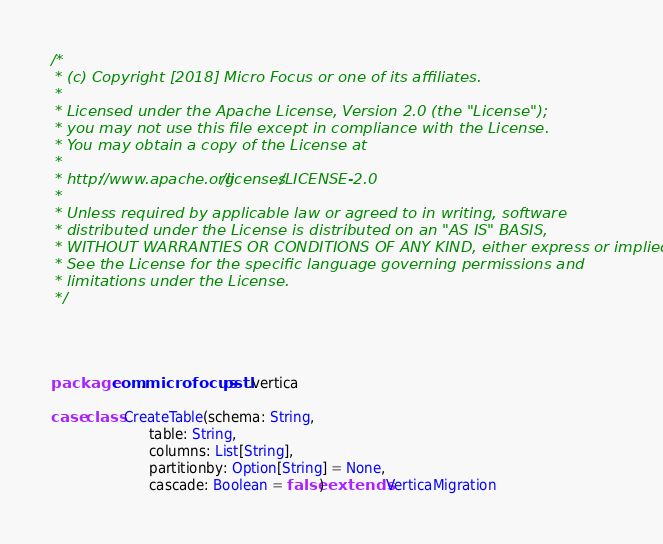Convert code to text. <code><loc_0><loc_0><loc_500><loc_500><_Scala_>/*
 * (c) Copyright [2018] Micro Focus or one of its affiliates.
 *
 * Licensed under the Apache License, Version 2.0 (the "License");
 * you may not use this file except in compliance with the License.
 * You may obtain a copy of the License at
 *
 * http://www.apache.org/licenses/LICENSE-2.0
 *
 * Unless required by applicable law or agreed to in writing, software
 * distributed under the License is distributed on an "AS IS" BASIS,
 * WITHOUT WARRANTIES OR CONDITIONS OF ANY KIND, either express or implied.
 * See the License for the specific language governing permissions and
 * limitations under the License.
 */ 




package com.microfocus.pstl.vertica

case class CreateTable(schema: String,
                       table: String,
                       columns: List[String],
                       partitionby: Option[String] = None,
                       cascade: Boolean = false) extends VerticaMigration
</code> 